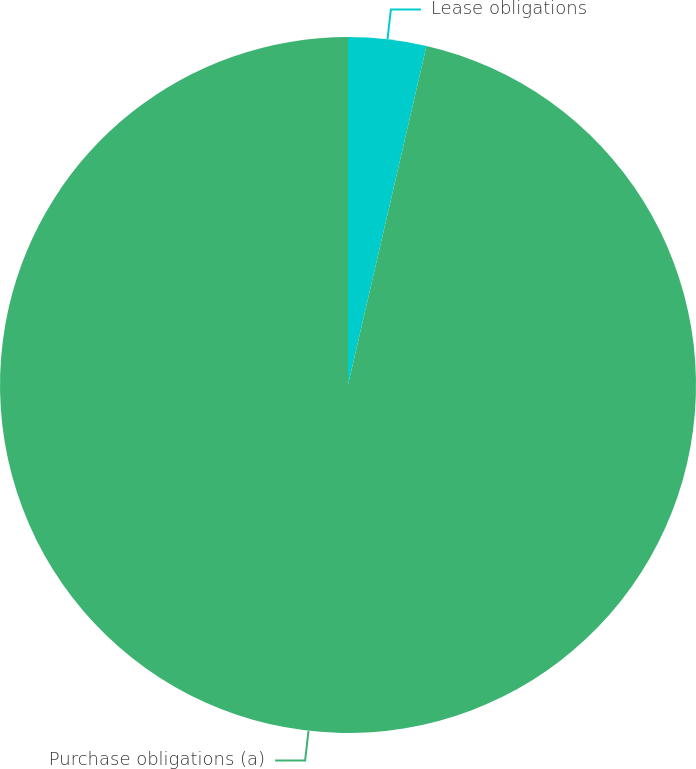Convert chart to OTSL. <chart><loc_0><loc_0><loc_500><loc_500><pie_chart><fcel>Lease obligations<fcel>Purchase obligations (a)<nl><fcel>3.62%<fcel>96.38%<nl></chart> 